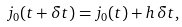Convert formula to latex. <formula><loc_0><loc_0><loc_500><loc_500>j _ { 0 } ( t + \delta { t } ) = j _ { 0 } ( t ) + h \, \delta { t } ,</formula> 